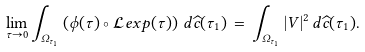Convert formula to latex. <formula><loc_0><loc_0><loc_500><loc_500>\lim _ { \tau \rightarrow 0 } \int _ { \Omega _ { \tau _ { 1 } } } \left ( \phi ( \tau ) \circ { \mathcal { L } } e x p ( { \tau } ) \right ) \, d \widehat { c } ( \tau _ { 1 } ) \, = \, \int _ { \Omega _ { \tau _ { 1 } } } | V | ^ { 2 } \, d \widehat { c } ( \tau _ { 1 } ) .</formula> 